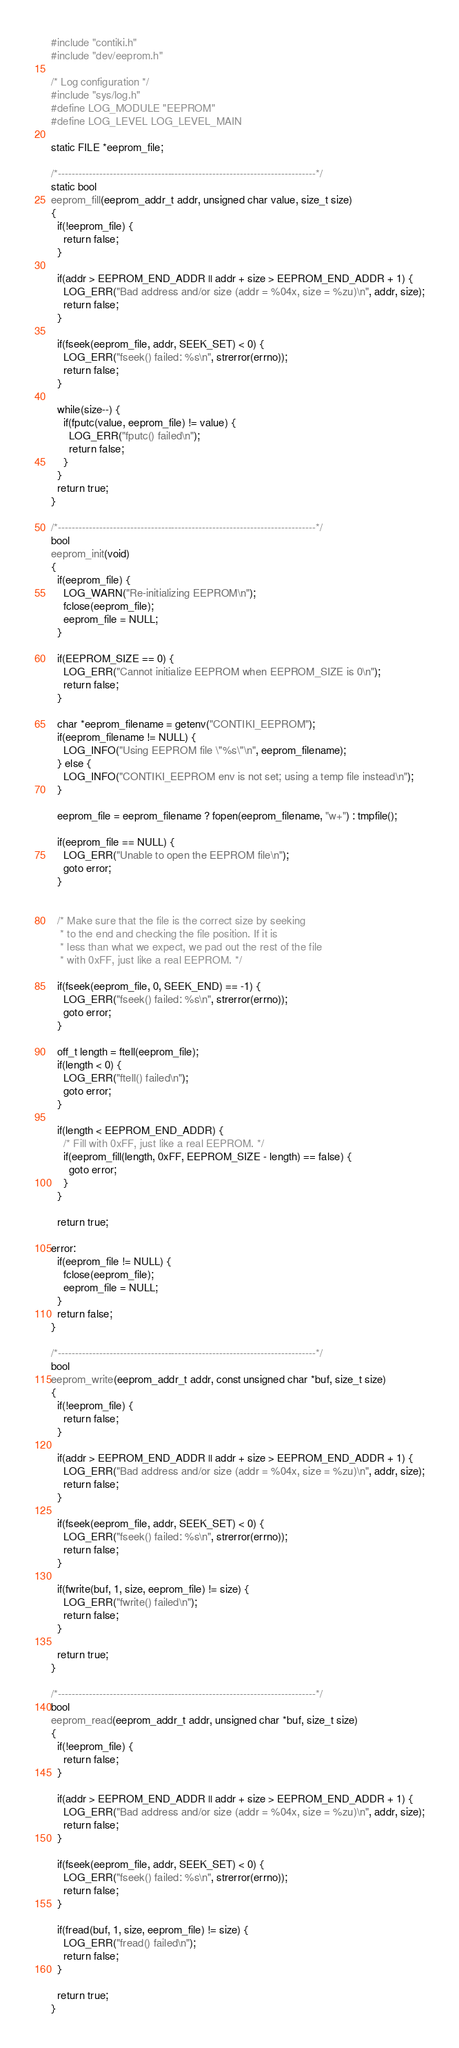Convert code to text. <code><loc_0><loc_0><loc_500><loc_500><_C_>
#include "contiki.h"
#include "dev/eeprom.h"

/* Log configuration */
#include "sys/log.h"
#define LOG_MODULE "EEPROM"
#define LOG_LEVEL LOG_LEVEL_MAIN

static FILE *eeprom_file;

/*---------------------------------------------------------------------------*/
static bool
eeprom_fill(eeprom_addr_t addr, unsigned char value, size_t size)
{
  if(!eeprom_file) {
    return false;
  }

  if(addr > EEPROM_END_ADDR || addr + size > EEPROM_END_ADDR + 1) {
    LOG_ERR("Bad address and/or size (addr = %04x, size = %zu)\n", addr, size);
    return false;
  }

  if(fseek(eeprom_file, addr, SEEK_SET) < 0) {
    LOG_ERR("fseek() failed: %s\n", strerror(errno));
    return false;
  }

  while(size--) {
    if(fputc(value, eeprom_file) != value) {
      LOG_ERR("fputc() failed\n");
      return false;
    }
  }
  return true;
}

/*---------------------------------------------------------------------------*/
bool
eeprom_init(void)
{
  if(eeprom_file) {
    LOG_WARN("Re-initializing EEPROM\n");
    fclose(eeprom_file);
    eeprom_file = NULL;
  }

  if(EEPROM_SIZE == 0) {
    LOG_ERR("Cannot initialize EEPROM when EEPROM_SIZE is 0\n");
    return false;
  }

  char *eeprom_filename = getenv("CONTIKI_EEPROM");
  if(eeprom_filename != NULL) {
    LOG_INFO("Using EEPROM file \"%s\"\n", eeprom_filename);
  } else {
    LOG_INFO("CONTIKI_EEPROM env is not set; using a temp file instead\n");
  }

  eeprom_file = eeprom_filename ? fopen(eeprom_filename, "w+") : tmpfile();

  if(eeprom_file == NULL) {
    LOG_ERR("Unable to open the EEPROM file\n");
    goto error;
  }


  /* Make sure that the file is the correct size by seeking
   * to the end and checking the file position. If it is
   * less than what we expect, we pad out the rest of the file
   * with 0xFF, just like a real EEPROM. */

  if(fseek(eeprom_file, 0, SEEK_END) == -1) {
    LOG_ERR("fseek() failed: %s\n", strerror(errno));
    goto error;
  }

  off_t length = ftell(eeprom_file);
  if(length < 0) {
    LOG_ERR("ftell() failed\n");
    goto error;
  }

  if(length < EEPROM_END_ADDR) {
    /* Fill with 0xFF, just like a real EEPROM. */
    if(eeprom_fill(length, 0xFF, EEPROM_SIZE - length) == false) {
      goto error;
    }
  }

  return true;

error:
  if(eeprom_file != NULL) {
    fclose(eeprom_file);
    eeprom_file = NULL;
  }
  return false;
}

/*---------------------------------------------------------------------------*/
bool
eeprom_write(eeprom_addr_t addr, const unsigned char *buf, size_t size)
{
  if(!eeprom_file) {
    return false;
  }

  if(addr > EEPROM_END_ADDR || addr + size > EEPROM_END_ADDR + 1) {
    LOG_ERR("Bad address and/or size (addr = %04x, size = %zu)\n", addr, size);
    return false;
  }

  if(fseek(eeprom_file, addr, SEEK_SET) < 0) {
    LOG_ERR("fseek() failed: %s\n", strerror(errno));
    return false;
  }

  if(fwrite(buf, 1, size, eeprom_file) != size) {
    LOG_ERR("fwrite() failed\n");
    return false;
  }

  return true;
}

/*---------------------------------------------------------------------------*/
bool
eeprom_read(eeprom_addr_t addr, unsigned char *buf, size_t size)
{
  if(!eeprom_file) {
    return false;
  }

  if(addr > EEPROM_END_ADDR || addr + size > EEPROM_END_ADDR + 1) {
    LOG_ERR("Bad address and/or size (addr = %04x, size = %zu)\n", addr, size);
    return false;
  }

  if(fseek(eeprom_file, addr, SEEK_SET) < 0) {
    LOG_ERR("fseek() failed: %s\n", strerror(errno));
    return false;
  }

  if(fread(buf, 1, size, eeprom_file) != size) {
    LOG_ERR("fread() failed\n");
    return false;
  }

  return true;
}
</code> 